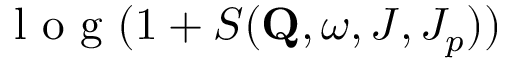<formula> <loc_0><loc_0><loc_500><loc_500>l o g ( 1 + S ( Q , \omega , J , J _ { p } ) )</formula> 